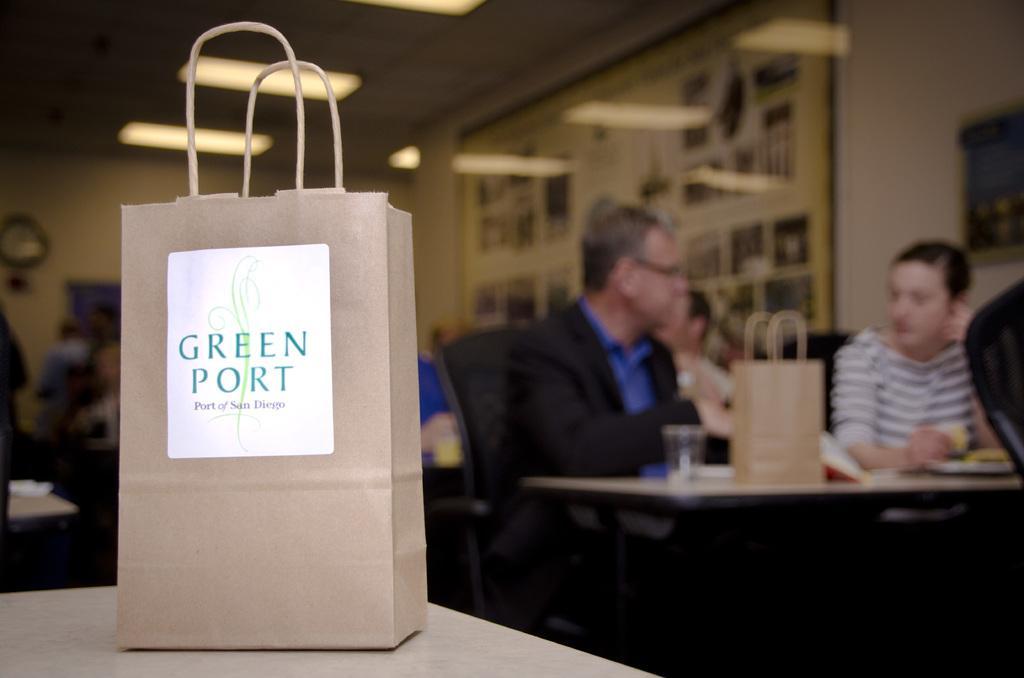Could you give a brief overview of what you see in this image? In the image there is a paper bag kept on a table, behind that bag there are few people, a table and there are some objects on the table. 